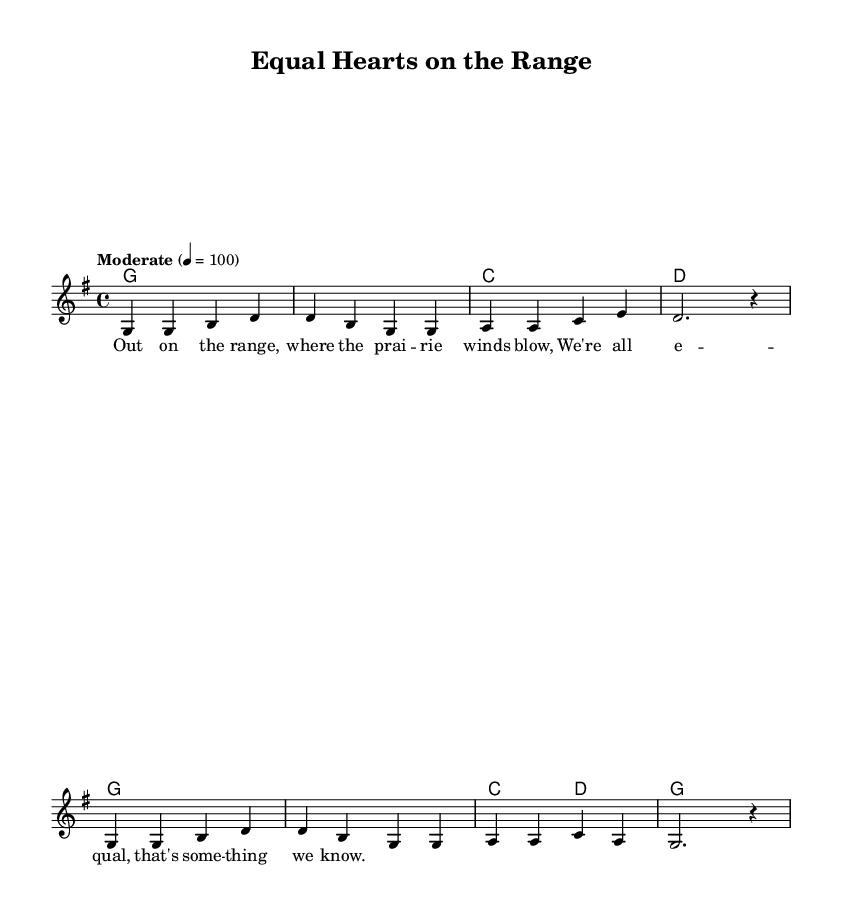What is the key signature of this music? The key signature is G major, which has one sharp (F#). This can be identified by looking at the key signature at the beginning of the staff.
Answer: G major What is the time signature of this music? The time signature is 4/4, which is indicated at the beginning of the score. This means there are four beats in each measure and the quarter note gets one beat.
Answer: 4/4 What is the tempo marking for the piece? The tempo marking is "Moderate" with a speed of 100 beats per minute, as indicated above the staff. This tells performers how fast to play the tune.
Answer: Moderate, 100 How many measures are in the melody section? By counting the number of times a vertical bar line appears in the melody, we find that there are 8 measures in total.
Answer: 8 What is the primary theme or message conveyed in the lyrics? The lyrics promote equality, as expressed in the line "We're all equal, that's something we know," which emphasizes the importance of gender equality.
Answer: Equality What type of harmony is used in this piece? The piece uses simple triadic harmony, as indicated by the chord symbols like G, C, and D written above the staff. This is common in country music for a straightforward sound.
Answer: Triadic harmony What style of music does this score represent? The score represents traditional country music, characterized by its straightforward melodies and themes, which can be deduced from the use of typical country chord progressions and lyrical content.
Answer: Traditional country 